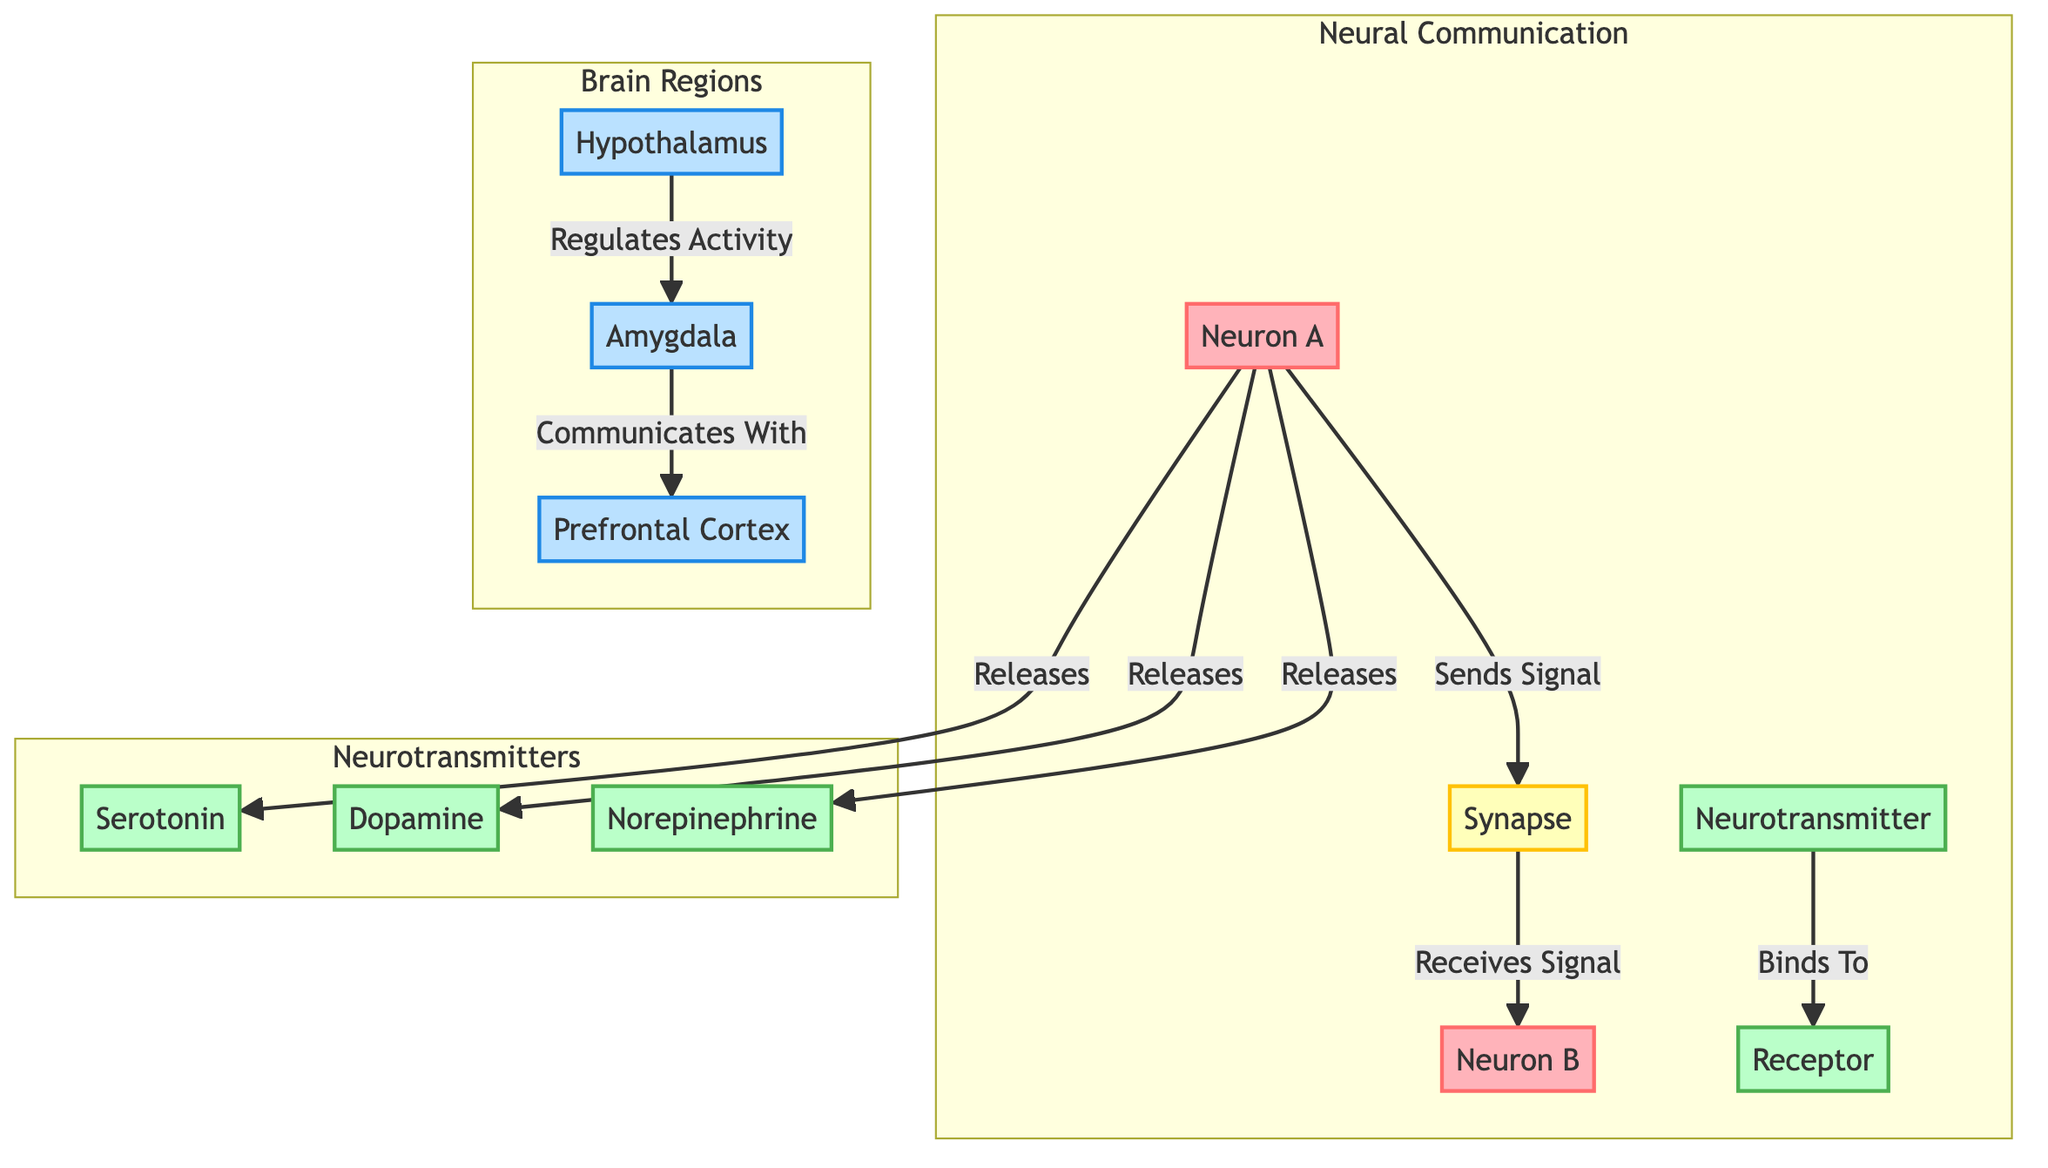What is the primary neurotransmitter released by Neuron A? According to the diagram, Neuron A releases multiple neurotransmitters, including Serotonin, Dopamine, and Norepinephrine. However, to identify the primary neurotransmitter, we observe it releases serotonin first in the flow from Neuron A.
Answer: Serotonin Which regions of the brain does the Hypothalamus interact with? The diagram illustrates that the Hypothalamus regulates the activity of the Amygdala and communicates with the Prefrontal Cortex. This shows the direct connections represented by arrows in the diagram.
Answer: Amygdala, Prefrontal Cortex What role does the Synapse play in neural communication? The diagram indicates that the Synapse acts as a point where Neuron A sends a signal to Neuron B. Therefore, it serves as the transmitting link between the two neurons in the neural communication pathway.
Answer: Sends Signal How many neurotransmitters are represented in this diagram? By counting the different types of neurotransmitters specified in the Neurotransmitters subgraph, there are three: Serotonin, Dopamine, and Norepinephrine. This can be confirmed from the visual representation in the diagram.
Answer: Three What type of relationship exists between the Amygdala and the Prefrontal Cortex? The diagram depicts that the Amygdala communicates with the Prefrontal Cortex, signifying a directional relationship where one region influences or sends information to the other in the brain structure.
Answer: Communicates With Which neuron sends a signal according to the diagram? The diagram clearly points out that Neuron A is responsible for sending the signal to the Synapse, thus identifying it as the neuron initiating the signal in this communication pathway.
Answer: Neuron A 